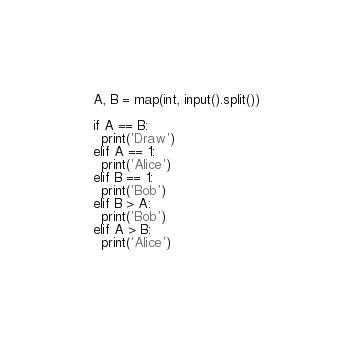<code> <loc_0><loc_0><loc_500><loc_500><_Python_>A, B = map(int, input().split())

if A == B:
  print('Draw')
elif A == 1:
  print('Alice') 
elif B == 1:
  print('Bob')
elif B > A:
  print('Bob')
elif A > B:
  print('Alice')</code> 